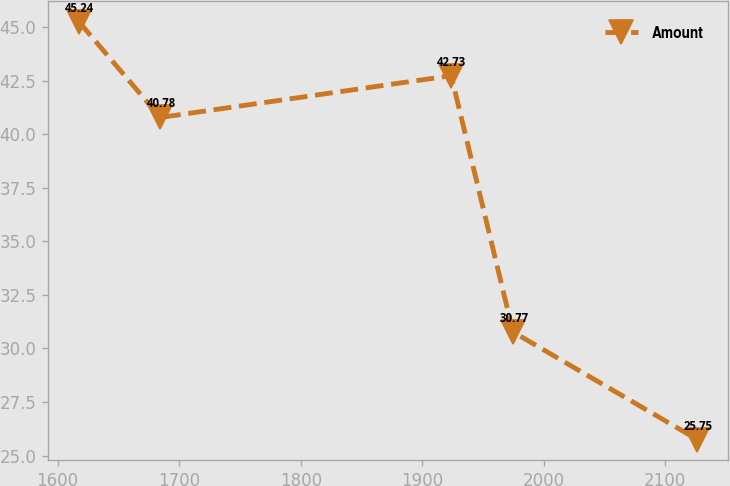<chart> <loc_0><loc_0><loc_500><loc_500><line_chart><ecel><fcel>Amount<nl><fcel>1617.58<fcel>45.24<nl><fcel>1684.5<fcel>40.78<nl><fcel>1923.8<fcel>42.73<nl><fcel>1974.68<fcel>30.77<nl><fcel>2126.36<fcel>25.75<nl></chart> 